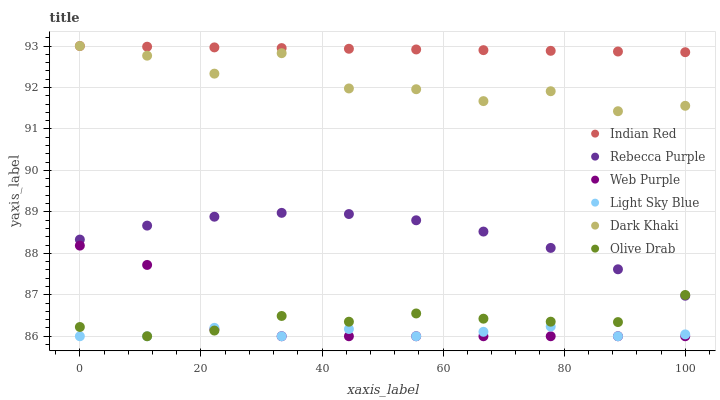Does Light Sky Blue have the minimum area under the curve?
Answer yes or no. Yes. Does Indian Red have the maximum area under the curve?
Answer yes or no. Yes. Does Web Purple have the minimum area under the curve?
Answer yes or no. No. Does Web Purple have the maximum area under the curve?
Answer yes or no. No. Is Indian Red the smoothest?
Answer yes or no. Yes. Is Dark Khaki the roughest?
Answer yes or no. Yes. Is Web Purple the smoothest?
Answer yes or no. No. Is Web Purple the roughest?
Answer yes or no. No. Does Web Purple have the lowest value?
Answer yes or no. Yes. Does Rebecca Purple have the lowest value?
Answer yes or no. No. Does Indian Red have the highest value?
Answer yes or no. Yes. Does Web Purple have the highest value?
Answer yes or no. No. Is Web Purple less than Indian Red?
Answer yes or no. Yes. Is Indian Red greater than Olive Drab?
Answer yes or no. Yes. Does Olive Drab intersect Rebecca Purple?
Answer yes or no. Yes. Is Olive Drab less than Rebecca Purple?
Answer yes or no. No. Is Olive Drab greater than Rebecca Purple?
Answer yes or no. No. Does Web Purple intersect Indian Red?
Answer yes or no. No. 